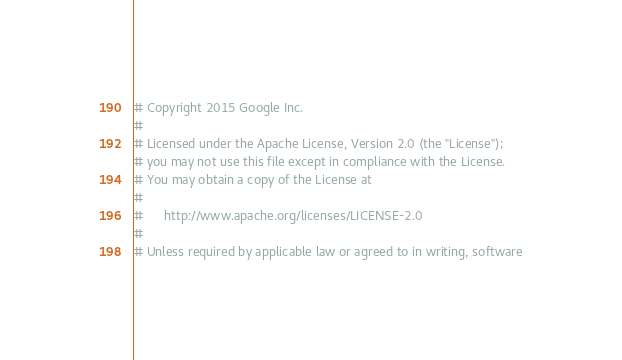Convert code to text. <code><loc_0><loc_0><loc_500><loc_500><_Ruby_># Copyright 2015 Google Inc.
#
# Licensed under the Apache License, Version 2.0 (the "License");
# you may not use this file except in compliance with the License.
# You may obtain a copy of the License at
#
#      http://www.apache.org/licenses/LICENSE-2.0
#
# Unless required by applicable law or agreed to in writing, software</code> 